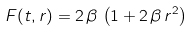Convert formula to latex. <formula><loc_0><loc_0><loc_500><loc_500>F ( t , r ) = 2 \, \beta \, \left ( 1 + 2 \, \beta \, r ^ { 2 } \right )</formula> 